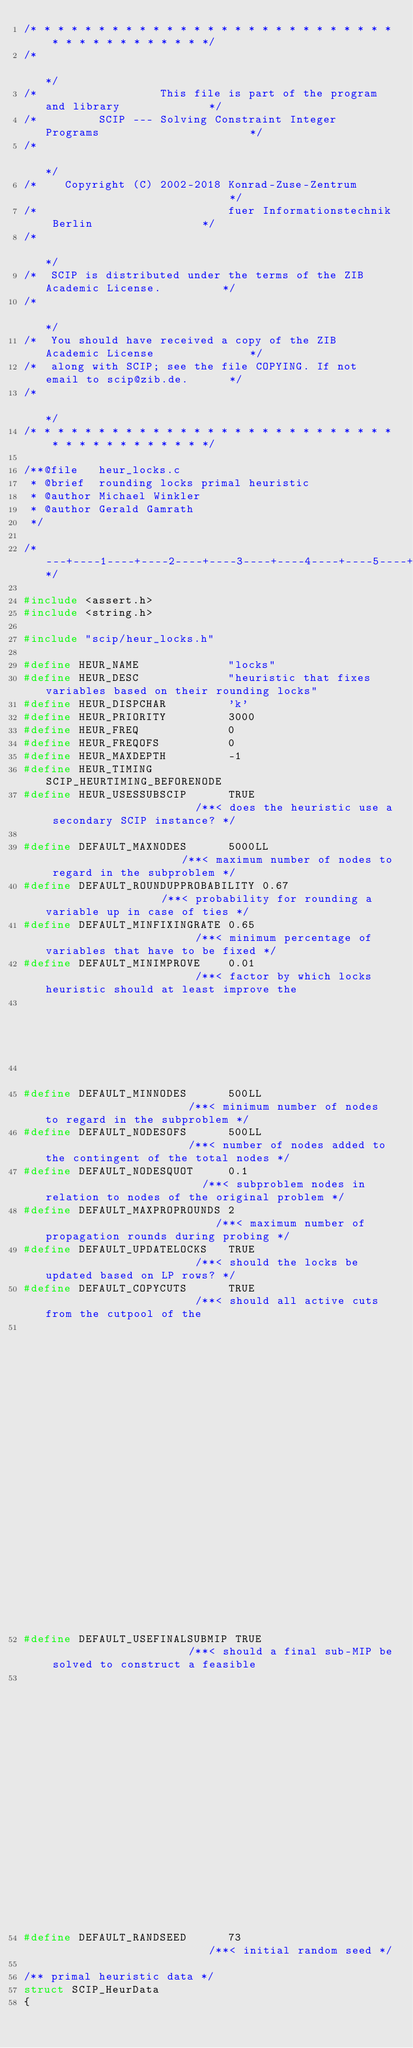<code> <loc_0><loc_0><loc_500><loc_500><_C_>/* * * * * * * * * * * * * * * * * * * * * * * * * * * * * * * * * * * * * * */
/*                                                                           */
/*                  This file is part of the program and library             */
/*         SCIP --- Solving Constraint Integer Programs                      */
/*                                                                           */
/*    Copyright (C) 2002-2018 Konrad-Zuse-Zentrum                            */
/*                            fuer Informationstechnik Berlin                */
/*                                                                           */
/*  SCIP is distributed under the terms of the ZIB Academic License.         */
/*                                                                           */
/*  You should have received a copy of the ZIB Academic License              */
/*  along with SCIP; see the file COPYING. If not email to scip@zib.de.      */
/*                                                                           */
/* * * * * * * * * * * * * * * * * * * * * * * * * * * * * * * * * * * * * * */

/**@file   heur_locks.c
 * @brief  rounding locks primal heuristic
 * @author Michael Winkler
 * @author Gerald Gamrath
 */

/*---+----1----+----2----+----3----+----4----+----5----+----6----+----7----+----8----+----9----+----0----+----1----+----2*/

#include <assert.h>
#include <string.h>

#include "scip/heur_locks.h"

#define HEUR_NAME             "locks"
#define HEUR_DESC             "heuristic that fixes variables based on their rounding locks"
#define HEUR_DISPCHAR         'k'
#define HEUR_PRIORITY         3000
#define HEUR_FREQ             0
#define HEUR_FREQOFS          0
#define HEUR_MAXDEPTH         -1
#define HEUR_TIMING           SCIP_HEURTIMING_BEFORENODE
#define HEUR_USESSUBSCIP      TRUE                       /**< does the heuristic use a secondary SCIP instance? */

#define DEFAULT_MAXNODES      5000LL                     /**< maximum number of nodes to regard in the subproblem */
#define DEFAULT_ROUNDUPPROBABILITY 0.67                  /**< probability for rounding a variable up in case of ties */
#define DEFAULT_MINFIXINGRATE 0.65                       /**< minimum percentage of variables that have to be fixed */
#define DEFAULT_MINIMPROVE    0.01                       /**< factor by which locks heuristic should at least improve the
                                                          *   incumbent
                                                          */
#define DEFAULT_MINNODES      500LL                      /**< minimum number of nodes to regard in the subproblem */
#define DEFAULT_NODESOFS      500LL                      /**< number of nodes added to the contingent of the total nodes */
#define DEFAULT_NODESQUOT     0.1                        /**< subproblem nodes in relation to nodes of the original problem */
#define DEFAULT_MAXPROPROUNDS 2                          /**< maximum number of propagation rounds during probing */
#define DEFAULT_UPDATELOCKS   TRUE                       /**< should the locks be updated based on LP rows? */
#define DEFAULT_COPYCUTS      TRUE                       /**< should all active cuts from the cutpool of the
                                                          *   original scip be copied to constraints of the subscip? */
#define DEFAULT_USEFINALSUBMIP TRUE                      /**< should a final sub-MIP be solved to construct a feasible
                                                          *   solution if the LP was not roundable? */
#define DEFAULT_RANDSEED      73                         /**< initial random seed */

/** primal heuristic data */
struct SCIP_HeurData
{</code> 